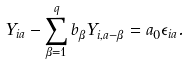Convert formula to latex. <formula><loc_0><loc_0><loc_500><loc_500>Y _ { i a } - \sum _ { \beta = 1 } ^ { q } b _ { \beta } Y _ { i , a - \beta } = a _ { 0 } \epsilon _ { i a } .</formula> 